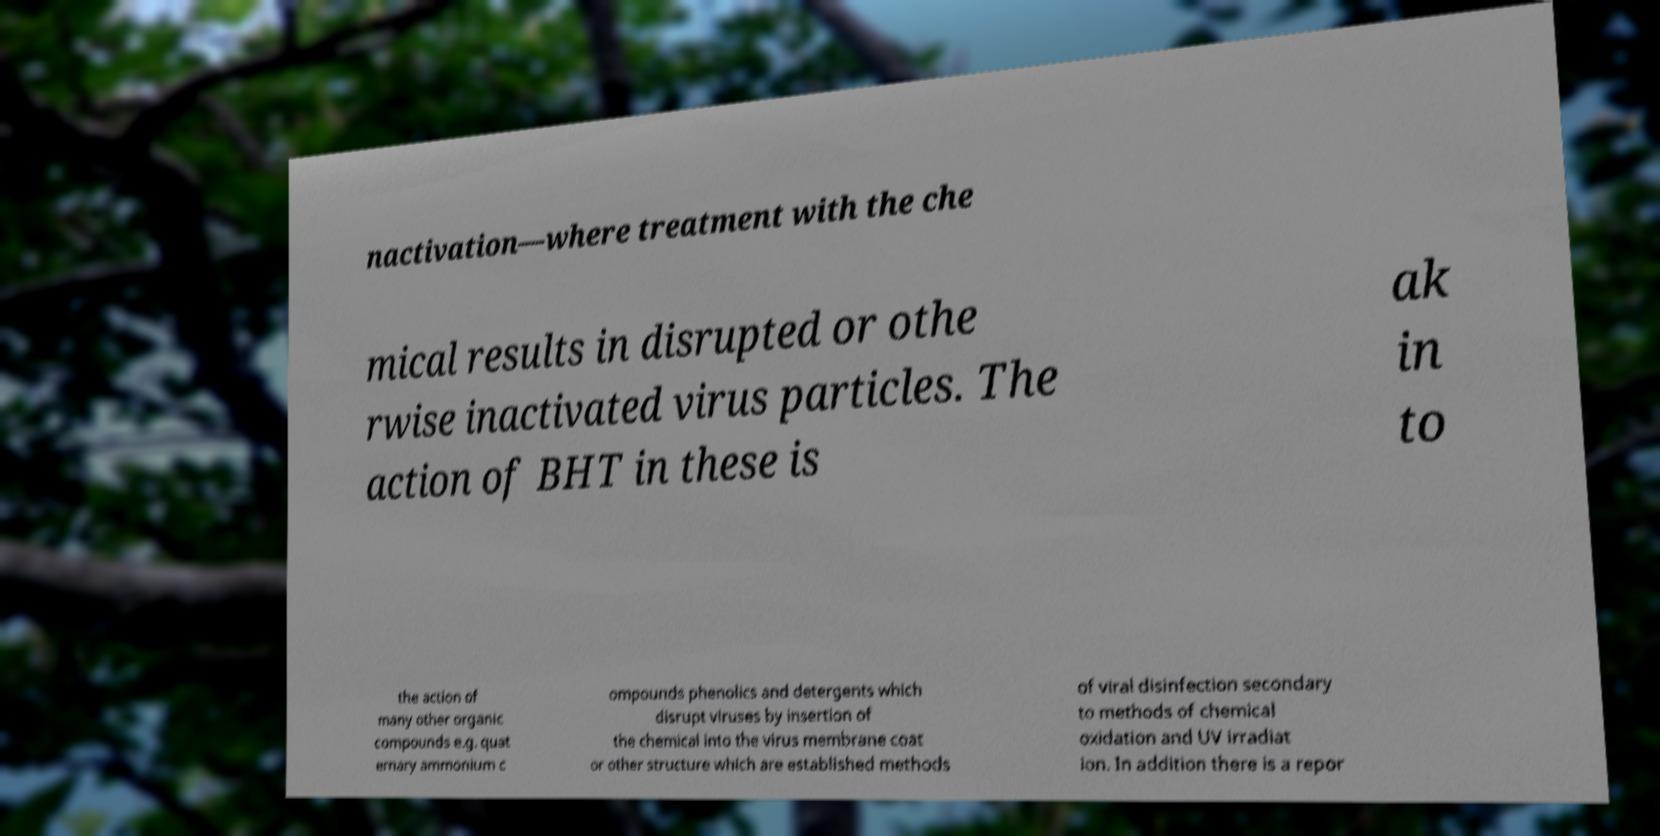There's text embedded in this image that I need extracted. Can you transcribe it verbatim? nactivation—where treatment with the che mical results in disrupted or othe rwise inactivated virus particles. The action of BHT in these is ak in to the action of many other organic compounds e.g. quat ernary ammonium c ompounds phenolics and detergents which disrupt viruses by insertion of the chemical into the virus membrane coat or other structure which are established methods of viral disinfection secondary to methods of chemical oxidation and UV irradiat ion. In addition there is a repor 